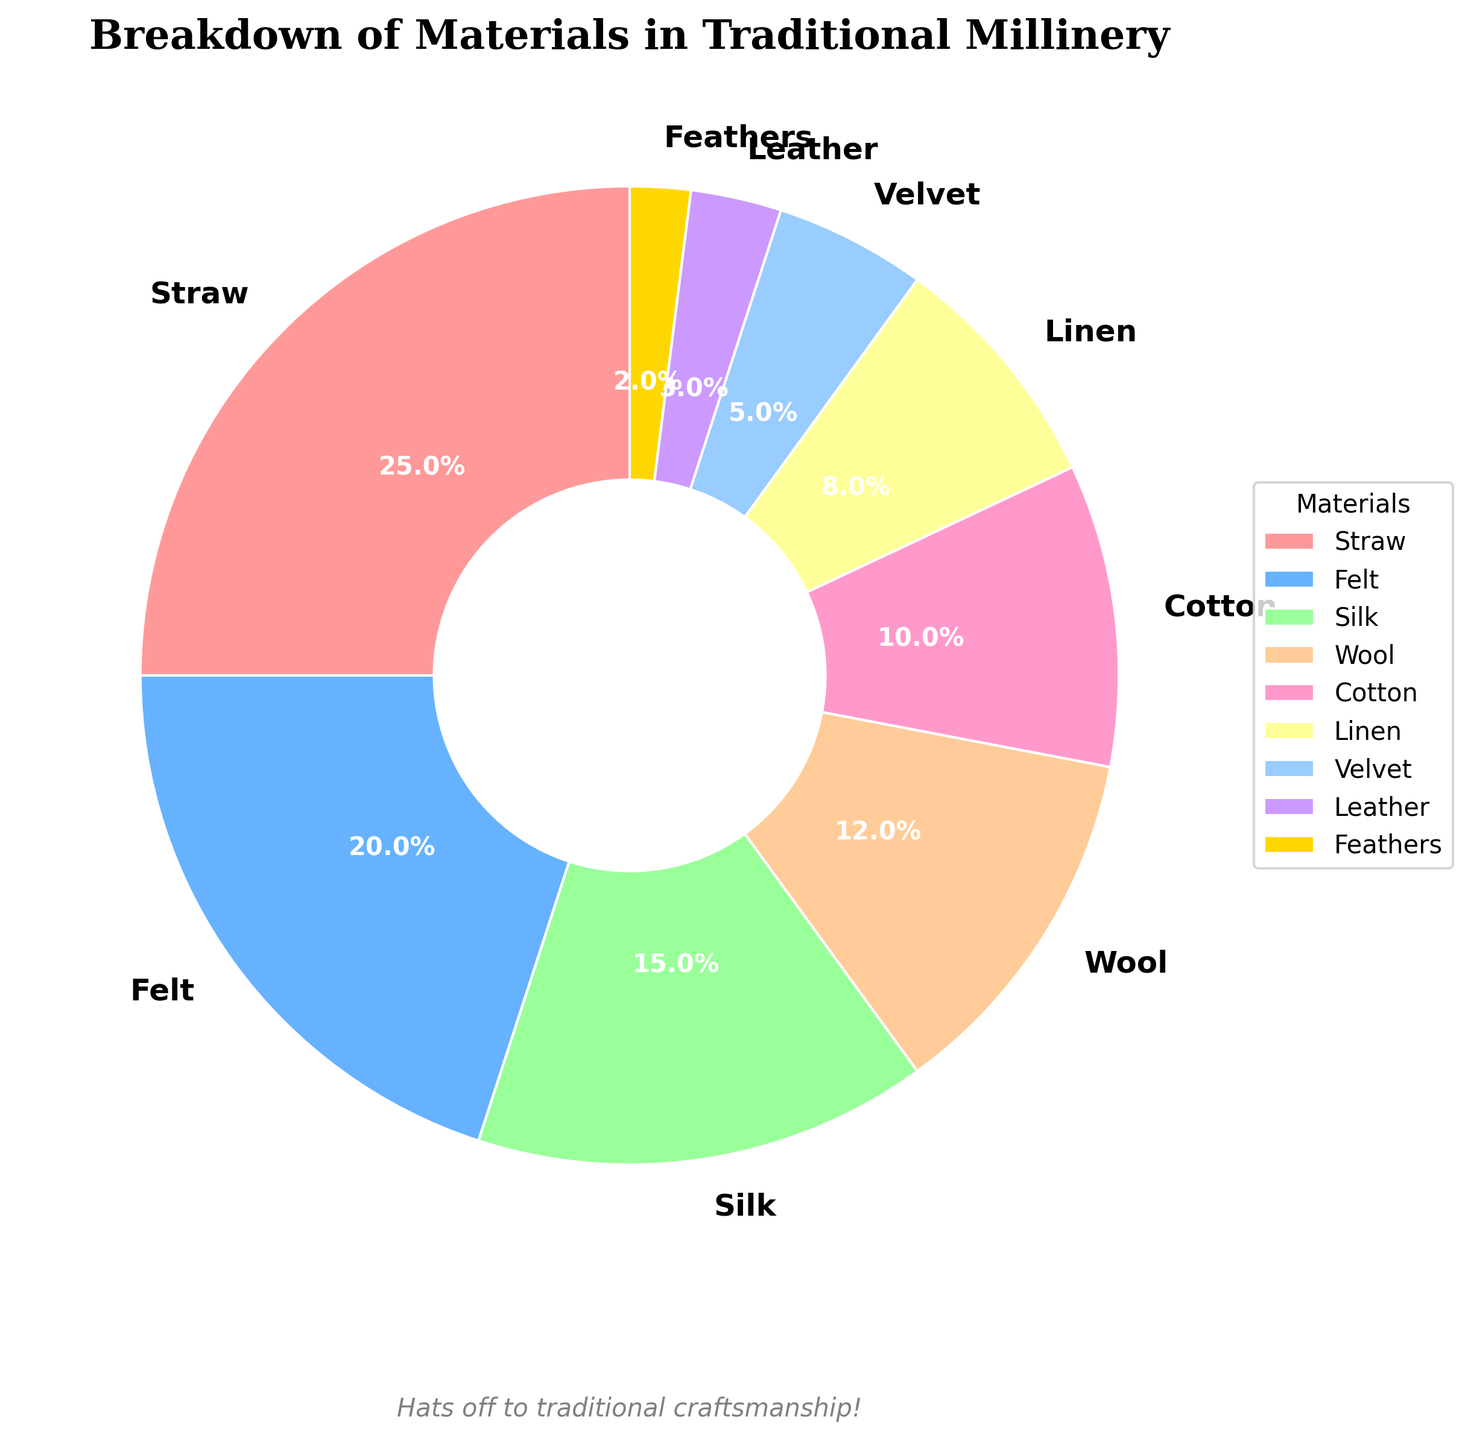Which material is used the most in traditional millinery? The chart shows that straw has the largest wedge with 25%, indicating that it is the most used material.
Answer: Straw How many materials collectively account for 45% of the distribution? Summing the percentages from the largest, straw at 25% and felt at 20%, gives a total of 45%.
Answer: Two Which materials make up less than 10% each? The chart shows that cotton (10%), linen (8%), velvet (5%), leather (3%), and feathers (2%) each have wedges smaller than 10%.
Answer: Cotton, Linen, Velvet, Leather, Feathers What is the combined percentage of the three least used materials? Adding the percentages of feathers (2%), leather (3%), and velvet (5%) gives a total of 10%.
Answer: 10% Is the percentage of silk usage higher or lower than the combined percentage of wool and cotton? Silk has 15%, while wool (12%) and cotton (10%) combined equal 22%, so silk is lower.
Answer: Lower Which materials are represented by shades of pink in the chart? The chart legend shows straw (25%) and velvet (5%) are in pink shades.
Answer: Straw, Velvet Among wool, cotton, and linen, which has the smallest slice visually? Linen has the smallest slice at 8% compared to wool's 12% and cotton's 10%.
Answer: Linen What's the difference between the usage percentages of the most and least used materials? The most used is straw at 25%, and the least used is feathers at 2%. The difference is 25% - 2% = 23%.
Answer: 23% Which material usage forms the smallest wedge, and what percentage does it cover? The chart shows that feathers form the smallest wedge with 2%.
Answer: Feathers, 2% If you combined the percentages of felt and wool, would they exceed the percentage of straw? Adding felt’s 20% and wool’s 12% gives 32%, which exceeds straw’s 25%.
Answer: Yes 